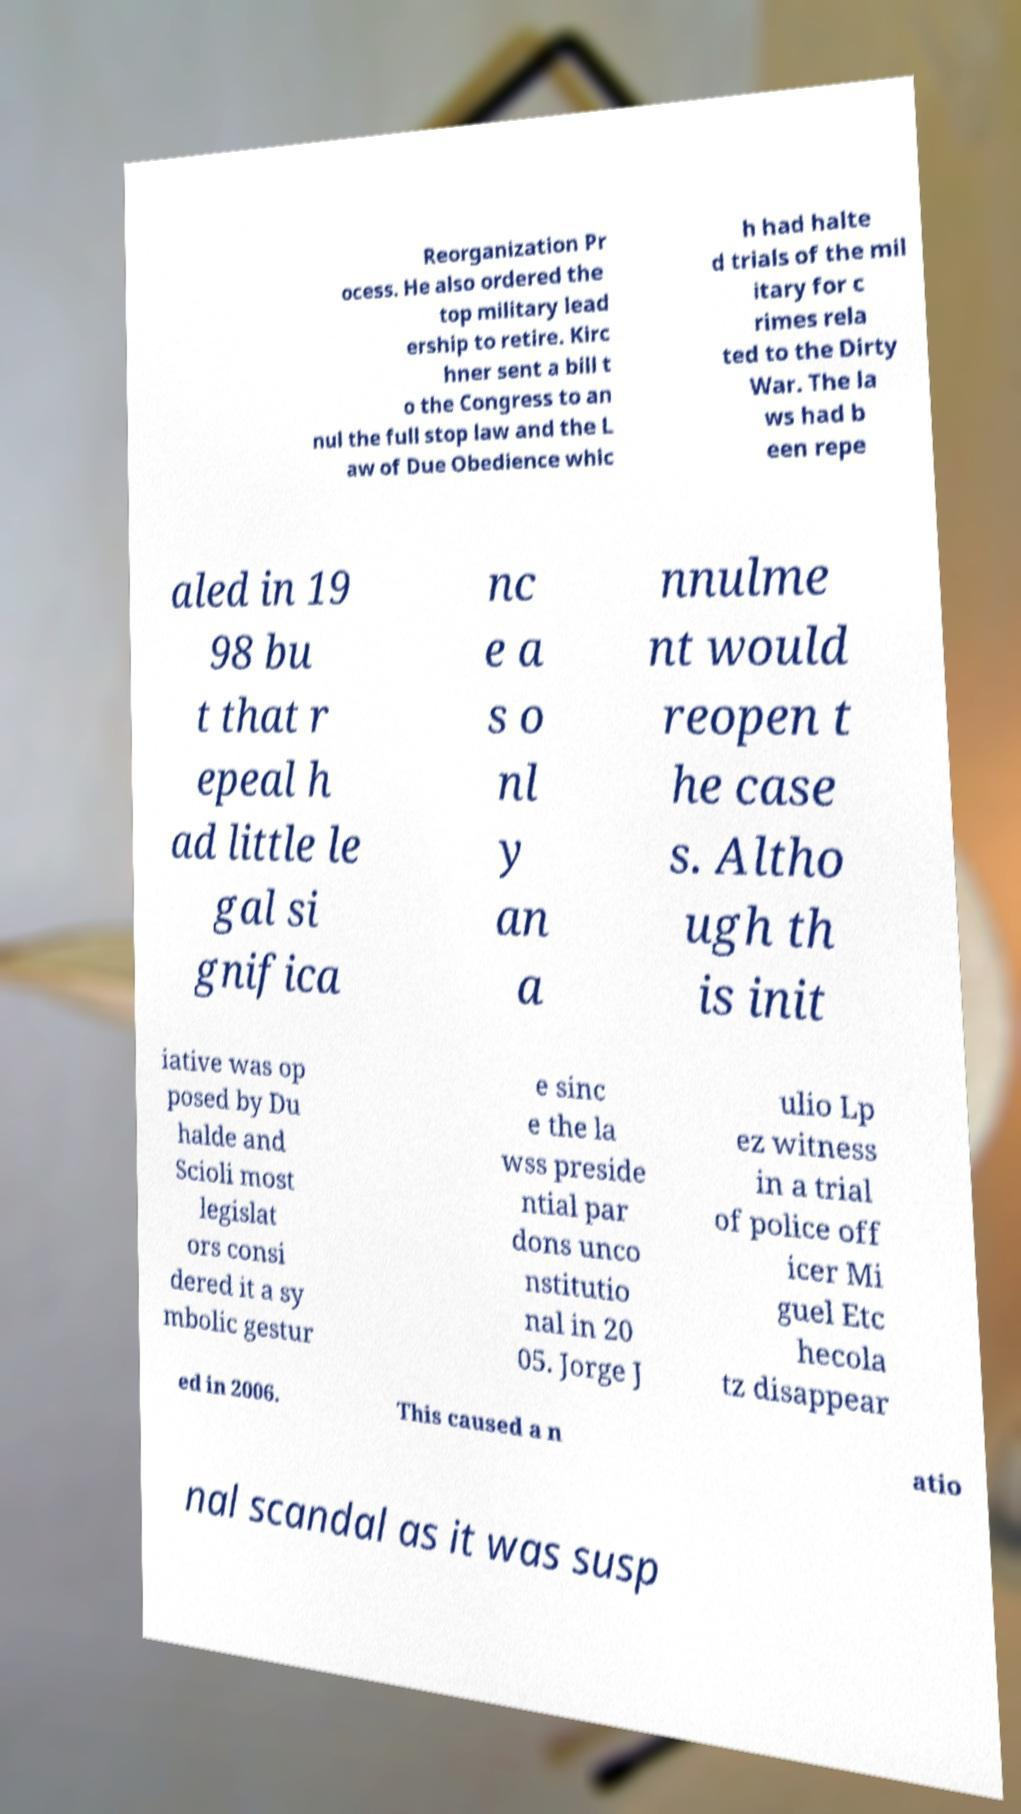For documentation purposes, I need the text within this image transcribed. Could you provide that? Reorganization Pr ocess. He also ordered the top military lead ership to retire. Kirc hner sent a bill t o the Congress to an nul the full stop law and the L aw of Due Obedience whic h had halte d trials of the mil itary for c rimes rela ted to the Dirty War. The la ws had b een repe aled in 19 98 bu t that r epeal h ad little le gal si gnifica nc e a s o nl y an a nnulme nt would reopen t he case s. Altho ugh th is init iative was op posed by Du halde and Scioli most legislat ors consi dered it a sy mbolic gestur e sinc e the la wss preside ntial par dons unco nstitutio nal in 20 05. Jorge J ulio Lp ez witness in a trial of police off icer Mi guel Etc hecola tz disappear ed in 2006. This caused a n atio nal scandal as it was susp 